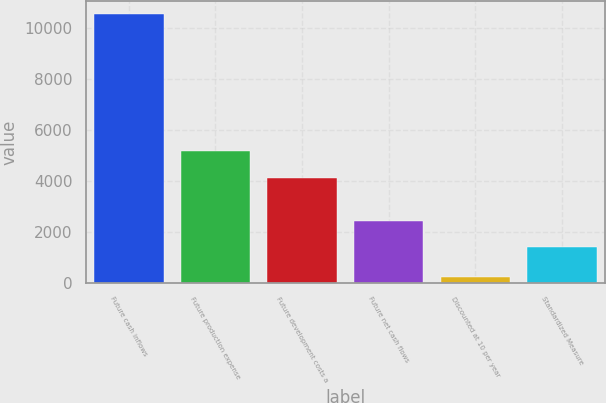Convert chart to OTSL. <chart><loc_0><loc_0><loc_500><loc_500><bar_chart><fcel>Future cash inflows<fcel>Future production expense<fcel>Future development costs a<fcel>Future net cash flows<fcel>Discounted at 10 per year<fcel>Standardized Measure<nl><fcel>10536<fcel>5159<fcel>4130<fcel>2421<fcel>246<fcel>1392<nl></chart> 